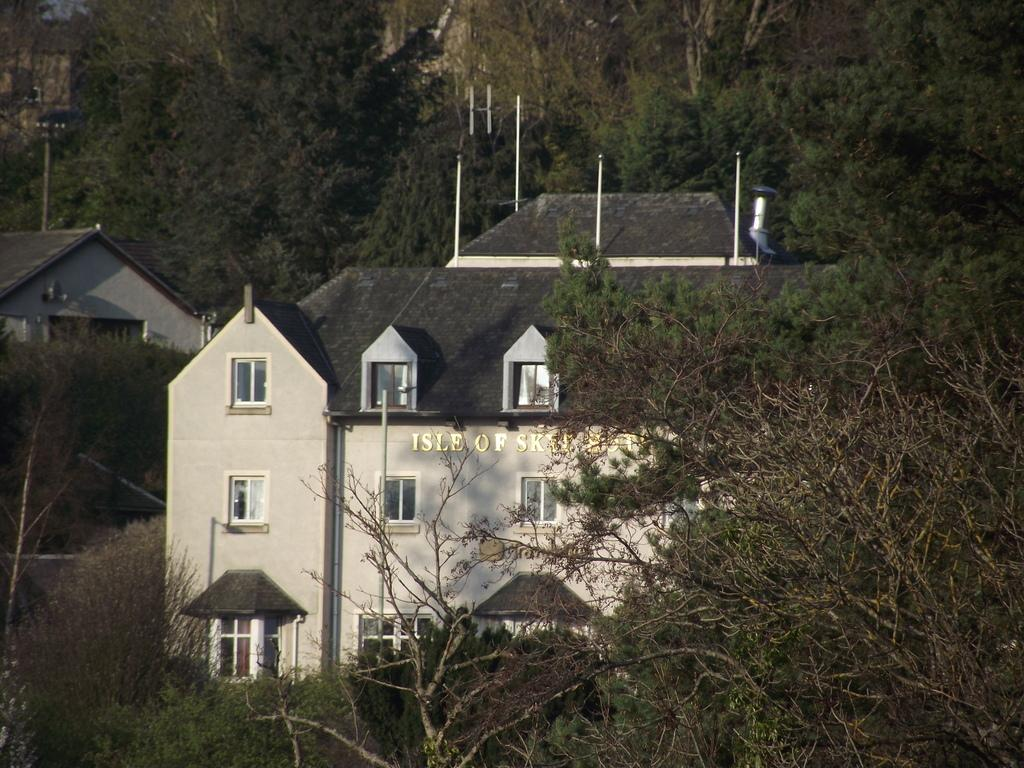What is located in the foreground of the image? There are trees and two houses in the foreground of the image. Can you describe the trees in the image? The trees in the foreground of the image are visible. How many houses can be seen in the foreground of the image? There are two houses in the foreground of the image. What type of mine is located near the houses in the image? There is no mine present in the image; it only features trees and two houses in the foreground. What country is depicted in the image? The image does not depict a specific country; it only shows trees and houses in the foreground. 